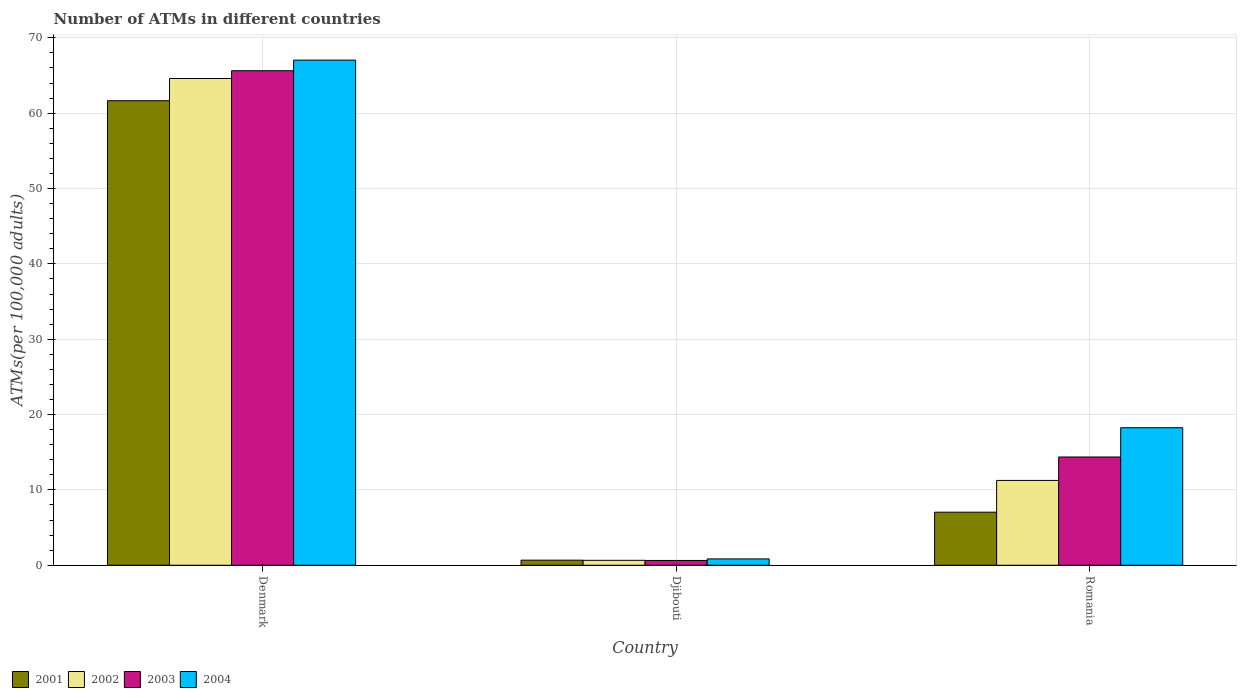How many different coloured bars are there?
Offer a very short reply. 4. Are the number of bars per tick equal to the number of legend labels?
Your response must be concise. Yes. Are the number of bars on each tick of the X-axis equal?
Your answer should be compact. Yes. How many bars are there on the 1st tick from the right?
Offer a terse response. 4. What is the label of the 1st group of bars from the left?
Provide a succinct answer. Denmark. In how many cases, is the number of bars for a given country not equal to the number of legend labels?
Keep it short and to the point. 0. What is the number of ATMs in 2001 in Romania?
Make the answer very short. 7.04. Across all countries, what is the maximum number of ATMs in 2002?
Offer a terse response. 64.61. Across all countries, what is the minimum number of ATMs in 2004?
Offer a terse response. 0.84. In which country was the number of ATMs in 2002 minimum?
Provide a short and direct response. Djibouti. What is the total number of ATMs in 2001 in the graph?
Make the answer very short. 69.38. What is the difference between the number of ATMs in 2001 in Denmark and that in Djibouti?
Provide a short and direct response. 60.98. What is the difference between the number of ATMs in 2002 in Djibouti and the number of ATMs in 2001 in Denmark?
Provide a short and direct response. -61. What is the average number of ATMs in 2001 per country?
Give a very brief answer. 23.13. What is the difference between the number of ATMs of/in 2002 and number of ATMs of/in 2003 in Romania?
Your response must be concise. -3.11. In how many countries, is the number of ATMs in 2001 greater than 32?
Offer a very short reply. 1. What is the ratio of the number of ATMs in 2002 in Denmark to that in Romania?
Ensure brevity in your answer.  5.74. Is the difference between the number of ATMs in 2002 in Denmark and Djibouti greater than the difference between the number of ATMs in 2003 in Denmark and Djibouti?
Give a very brief answer. No. What is the difference between the highest and the second highest number of ATMs in 2003?
Offer a terse response. -65. What is the difference between the highest and the lowest number of ATMs in 2002?
Your answer should be compact. 63.95. Is it the case that in every country, the sum of the number of ATMs in 2001 and number of ATMs in 2003 is greater than the sum of number of ATMs in 2002 and number of ATMs in 2004?
Your answer should be compact. No. What does the 2nd bar from the right in Romania represents?
Keep it short and to the point. 2003. Are all the bars in the graph horizontal?
Your answer should be very brief. No. Are the values on the major ticks of Y-axis written in scientific E-notation?
Your answer should be compact. No. Does the graph contain grids?
Your answer should be compact. Yes. Where does the legend appear in the graph?
Provide a succinct answer. Bottom left. How are the legend labels stacked?
Offer a very short reply. Horizontal. What is the title of the graph?
Your answer should be very brief. Number of ATMs in different countries. What is the label or title of the X-axis?
Your response must be concise. Country. What is the label or title of the Y-axis?
Provide a short and direct response. ATMs(per 100,0 adults). What is the ATMs(per 100,000 adults) of 2001 in Denmark?
Your answer should be compact. 61.66. What is the ATMs(per 100,000 adults) of 2002 in Denmark?
Your answer should be compact. 64.61. What is the ATMs(per 100,000 adults) in 2003 in Denmark?
Provide a succinct answer. 65.64. What is the ATMs(per 100,000 adults) in 2004 in Denmark?
Keep it short and to the point. 67.04. What is the ATMs(per 100,000 adults) of 2001 in Djibouti?
Offer a terse response. 0.68. What is the ATMs(per 100,000 adults) in 2002 in Djibouti?
Provide a succinct answer. 0.66. What is the ATMs(per 100,000 adults) in 2003 in Djibouti?
Your answer should be very brief. 0.64. What is the ATMs(per 100,000 adults) in 2004 in Djibouti?
Your answer should be very brief. 0.84. What is the ATMs(per 100,000 adults) in 2001 in Romania?
Offer a terse response. 7.04. What is the ATMs(per 100,000 adults) in 2002 in Romania?
Your answer should be compact. 11.26. What is the ATMs(per 100,000 adults) in 2003 in Romania?
Give a very brief answer. 14.37. What is the ATMs(per 100,000 adults) in 2004 in Romania?
Make the answer very short. 18.26. Across all countries, what is the maximum ATMs(per 100,000 adults) in 2001?
Your answer should be compact. 61.66. Across all countries, what is the maximum ATMs(per 100,000 adults) in 2002?
Your answer should be very brief. 64.61. Across all countries, what is the maximum ATMs(per 100,000 adults) of 2003?
Give a very brief answer. 65.64. Across all countries, what is the maximum ATMs(per 100,000 adults) in 2004?
Provide a succinct answer. 67.04. Across all countries, what is the minimum ATMs(per 100,000 adults) of 2001?
Give a very brief answer. 0.68. Across all countries, what is the minimum ATMs(per 100,000 adults) in 2002?
Provide a short and direct response. 0.66. Across all countries, what is the minimum ATMs(per 100,000 adults) in 2003?
Offer a terse response. 0.64. Across all countries, what is the minimum ATMs(per 100,000 adults) in 2004?
Give a very brief answer. 0.84. What is the total ATMs(per 100,000 adults) of 2001 in the graph?
Give a very brief answer. 69.38. What is the total ATMs(per 100,000 adults) in 2002 in the graph?
Offer a terse response. 76.52. What is the total ATMs(per 100,000 adults) in 2003 in the graph?
Your response must be concise. 80.65. What is the total ATMs(per 100,000 adults) in 2004 in the graph?
Ensure brevity in your answer.  86.14. What is the difference between the ATMs(per 100,000 adults) in 2001 in Denmark and that in Djibouti?
Offer a terse response. 60.98. What is the difference between the ATMs(per 100,000 adults) in 2002 in Denmark and that in Djibouti?
Offer a terse response. 63.95. What is the difference between the ATMs(per 100,000 adults) of 2003 in Denmark and that in Djibouti?
Make the answer very short. 65. What is the difference between the ATMs(per 100,000 adults) in 2004 in Denmark and that in Djibouti?
Your response must be concise. 66.2. What is the difference between the ATMs(per 100,000 adults) of 2001 in Denmark and that in Romania?
Ensure brevity in your answer.  54.61. What is the difference between the ATMs(per 100,000 adults) of 2002 in Denmark and that in Romania?
Offer a very short reply. 53.35. What is the difference between the ATMs(per 100,000 adults) of 2003 in Denmark and that in Romania?
Give a very brief answer. 51.27. What is the difference between the ATMs(per 100,000 adults) in 2004 in Denmark and that in Romania?
Your answer should be compact. 48.79. What is the difference between the ATMs(per 100,000 adults) of 2001 in Djibouti and that in Romania?
Ensure brevity in your answer.  -6.37. What is the difference between the ATMs(per 100,000 adults) in 2002 in Djibouti and that in Romania?
Your answer should be very brief. -10.6. What is the difference between the ATMs(per 100,000 adults) in 2003 in Djibouti and that in Romania?
Ensure brevity in your answer.  -13.73. What is the difference between the ATMs(per 100,000 adults) in 2004 in Djibouti and that in Romania?
Your response must be concise. -17.41. What is the difference between the ATMs(per 100,000 adults) of 2001 in Denmark and the ATMs(per 100,000 adults) of 2002 in Djibouti?
Offer a very short reply. 61. What is the difference between the ATMs(per 100,000 adults) of 2001 in Denmark and the ATMs(per 100,000 adults) of 2003 in Djibouti?
Provide a short and direct response. 61.02. What is the difference between the ATMs(per 100,000 adults) in 2001 in Denmark and the ATMs(per 100,000 adults) in 2004 in Djibouti?
Ensure brevity in your answer.  60.81. What is the difference between the ATMs(per 100,000 adults) in 2002 in Denmark and the ATMs(per 100,000 adults) in 2003 in Djibouti?
Ensure brevity in your answer.  63.97. What is the difference between the ATMs(per 100,000 adults) of 2002 in Denmark and the ATMs(per 100,000 adults) of 2004 in Djibouti?
Your answer should be compact. 63.76. What is the difference between the ATMs(per 100,000 adults) in 2003 in Denmark and the ATMs(per 100,000 adults) in 2004 in Djibouti?
Keep it short and to the point. 64.79. What is the difference between the ATMs(per 100,000 adults) of 2001 in Denmark and the ATMs(per 100,000 adults) of 2002 in Romania?
Provide a succinct answer. 50.4. What is the difference between the ATMs(per 100,000 adults) in 2001 in Denmark and the ATMs(per 100,000 adults) in 2003 in Romania?
Give a very brief answer. 47.29. What is the difference between the ATMs(per 100,000 adults) in 2001 in Denmark and the ATMs(per 100,000 adults) in 2004 in Romania?
Ensure brevity in your answer.  43.4. What is the difference between the ATMs(per 100,000 adults) of 2002 in Denmark and the ATMs(per 100,000 adults) of 2003 in Romania?
Provide a succinct answer. 50.24. What is the difference between the ATMs(per 100,000 adults) of 2002 in Denmark and the ATMs(per 100,000 adults) of 2004 in Romania?
Your response must be concise. 46.35. What is the difference between the ATMs(per 100,000 adults) of 2003 in Denmark and the ATMs(per 100,000 adults) of 2004 in Romania?
Your answer should be very brief. 47.38. What is the difference between the ATMs(per 100,000 adults) in 2001 in Djibouti and the ATMs(per 100,000 adults) in 2002 in Romania?
Provide a short and direct response. -10.58. What is the difference between the ATMs(per 100,000 adults) of 2001 in Djibouti and the ATMs(per 100,000 adults) of 2003 in Romania?
Keep it short and to the point. -13.69. What is the difference between the ATMs(per 100,000 adults) of 2001 in Djibouti and the ATMs(per 100,000 adults) of 2004 in Romania?
Provide a succinct answer. -17.58. What is the difference between the ATMs(per 100,000 adults) of 2002 in Djibouti and the ATMs(per 100,000 adults) of 2003 in Romania?
Provide a succinct answer. -13.71. What is the difference between the ATMs(per 100,000 adults) of 2002 in Djibouti and the ATMs(per 100,000 adults) of 2004 in Romania?
Your response must be concise. -17.6. What is the difference between the ATMs(per 100,000 adults) in 2003 in Djibouti and the ATMs(per 100,000 adults) in 2004 in Romania?
Offer a very short reply. -17.62. What is the average ATMs(per 100,000 adults) of 2001 per country?
Provide a succinct answer. 23.13. What is the average ATMs(per 100,000 adults) of 2002 per country?
Provide a short and direct response. 25.51. What is the average ATMs(per 100,000 adults) of 2003 per country?
Make the answer very short. 26.88. What is the average ATMs(per 100,000 adults) of 2004 per country?
Offer a terse response. 28.71. What is the difference between the ATMs(per 100,000 adults) of 2001 and ATMs(per 100,000 adults) of 2002 in Denmark?
Offer a terse response. -2.95. What is the difference between the ATMs(per 100,000 adults) of 2001 and ATMs(per 100,000 adults) of 2003 in Denmark?
Provide a short and direct response. -3.98. What is the difference between the ATMs(per 100,000 adults) of 2001 and ATMs(per 100,000 adults) of 2004 in Denmark?
Give a very brief answer. -5.39. What is the difference between the ATMs(per 100,000 adults) in 2002 and ATMs(per 100,000 adults) in 2003 in Denmark?
Make the answer very short. -1.03. What is the difference between the ATMs(per 100,000 adults) of 2002 and ATMs(per 100,000 adults) of 2004 in Denmark?
Provide a short and direct response. -2.44. What is the difference between the ATMs(per 100,000 adults) in 2003 and ATMs(per 100,000 adults) in 2004 in Denmark?
Your response must be concise. -1.41. What is the difference between the ATMs(per 100,000 adults) in 2001 and ATMs(per 100,000 adults) in 2002 in Djibouti?
Ensure brevity in your answer.  0.02. What is the difference between the ATMs(per 100,000 adults) in 2001 and ATMs(per 100,000 adults) in 2003 in Djibouti?
Make the answer very short. 0.04. What is the difference between the ATMs(per 100,000 adults) of 2001 and ATMs(per 100,000 adults) of 2004 in Djibouti?
Offer a very short reply. -0.17. What is the difference between the ATMs(per 100,000 adults) in 2002 and ATMs(per 100,000 adults) in 2003 in Djibouti?
Make the answer very short. 0.02. What is the difference between the ATMs(per 100,000 adults) in 2002 and ATMs(per 100,000 adults) in 2004 in Djibouti?
Provide a short and direct response. -0.19. What is the difference between the ATMs(per 100,000 adults) of 2003 and ATMs(per 100,000 adults) of 2004 in Djibouti?
Keep it short and to the point. -0.21. What is the difference between the ATMs(per 100,000 adults) in 2001 and ATMs(per 100,000 adults) in 2002 in Romania?
Provide a short and direct response. -4.21. What is the difference between the ATMs(per 100,000 adults) of 2001 and ATMs(per 100,000 adults) of 2003 in Romania?
Your answer should be very brief. -7.32. What is the difference between the ATMs(per 100,000 adults) in 2001 and ATMs(per 100,000 adults) in 2004 in Romania?
Make the answer very short. -11.21. What is the difference between the ATMs(per 100,000 adults) of 2002 and ATMs(per 100,000 adults) of 2003 in Romania?
Offer a terse response. -3.11. What is the difference between the ATMs(per 100,000 adults) in 2002 and ATMs(per 100,000 adults) in 2004 in Romania?
Ensure brevity in your answer.  -7. What is the difference between the ATMs(per 100,000 adults) of 2003 and ATMs(per 100,000 adults) of 2004 in Romania?
Your answer should be very brief. -3.89. What is the ratio of the ATMs(per 100,000 adults) of 2001 in Denmark to that in Djibouti?
Your response must be concise. 91.18. What is the ratio of the ATMs(per 100,000 adults) of 2002 in Denmark to that in Djibouti?
Provide a succinct answer. 98.45. What is the ratio of the ATMs(per 100,000 adults) of 2003 in Denmark to that in Djibouti?
Provide a succinct answer. 102.88. What is the ratio of the ATMs(per 100,000 adults) of 2004 in Denmark to that in Djibouti?
Offer a terse response. 79.46. What is the ratio of the ATMs(per 100,000 adults) in 2001 in Denmark to that in Romania?
Offer a very short reply. 8.75. What is the ratio of the ATMs(per 100,000 adults) of 2002 in Denmark to that in Romania?
Provide a succinct answer. 5.74. What is the ratio of the ATMs(per 100,000 adults) in 2003 in Denmark to that in Romania?
Provide a short and direct response. 4.57. What is the ratio of the ATMs(per 100,000 adults) in 2004 in Denmark to that in Romania?
Give a very brief answer. 3.67. What is the ratio of the ATMs(per 100,000 adults) of 2001 in Djibouti to that in Romania?
Keep it short and to the point. 0.1. What is the ratio of the ATMs(per 100,000 adults) in 2002 in Djibouti to that in Romania?
Offer a terse response. 0.06. What is the ratio of the ATMs(per 100,000 adults) of 2003 in Djibouti to that in Romania?
Make the answer very short. 0.04. What is the ratio of the ATMs(per 100,000 adults) in 2004 in Djibouti to that in Romania?
Your answer should be compact. 0.05. What is the difference between the highest and the second highest ATMs(per 100,000 adults) in 2001?
Ensure brevity in your answer.  54.61. What is the difference between the highest and the second highest ATMs(per 100,000 adults) of 2002?
Make the answer very short. 53.35. What is the difference between the highest and the second highest ATMs(per 100,000 adults) of 2003?
Ensure brevity in your answer.  51.27. What is the difference between the highest and the second highest ATMs(per 100,000 adults) in 2004?
Offer a very short reply. 48.79. What is the difference between the highest and the lowest ATMs(per 100,000 adults) of 2001?
Offer a terse response. 60.98. What is the difference between the highest and the lowest ATMs(per 100,000 adults) of 2002?
Offer a terse response. 63.95. What is the difference between the highest and the lowest ATMs(per 100,000 adults) of 2003?
Ensure brevity in your answer.  65. What is the difference between the highest and the lowest ATMs(per 100,000 adults) in 2004?
Make the answer very short. 66.2. 